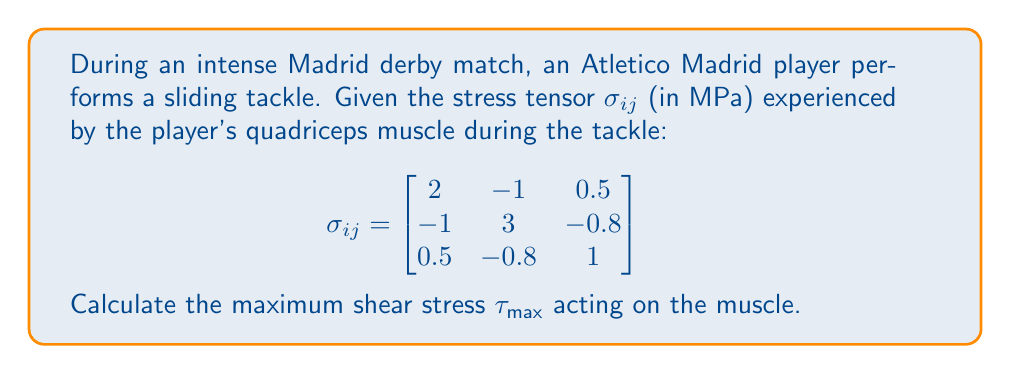Give your solution to this math problem. To find the maximum shear stress, we need to follow these steps:

1) First, we need to calculate the principal stresses. These are the eigenvalues of the stress tensor.

2) The characteristic equation for the eigenvalues is:
   $det(\sigma_{ij} - \lambda I) = 0$

3) Expanding this:
   $$\begin{vmatrix}
   2-\lambda & -1 & 0.5 \\
   -1 & 3-\lambda & -0.8 \\
   0.5 & -0.8 & 1-\lambda
   \end{vmatrix} = 0$$

4) This leads to the cubic equation:
   $-\lambda^3 + 6\lambda^2 - 10\lambda + 4 = 0$

5) Solving this equation (using a calculator or computer algebra system), we get:
   $\lambda_1 \approx 3.74$, $\lambda_2 \approx 1.67$, $\lambda_3 \approx 0.59$

6) The maximum shear stress is given by the formula:
   $$\tau_{max} = \frac{\sigma_{max} - \sigma_{min}}{2}$$

   where $\sigma_{max}$ is the largest principal stress and $\sigma_{min}$ is the smallest.

7) Therefore:
   $$\tau_{max} = \frac{3.74 - 0.59}{2} = 1.575 \text{ MPa}$$
Answer: $1.575 \text{ MPa}$ 